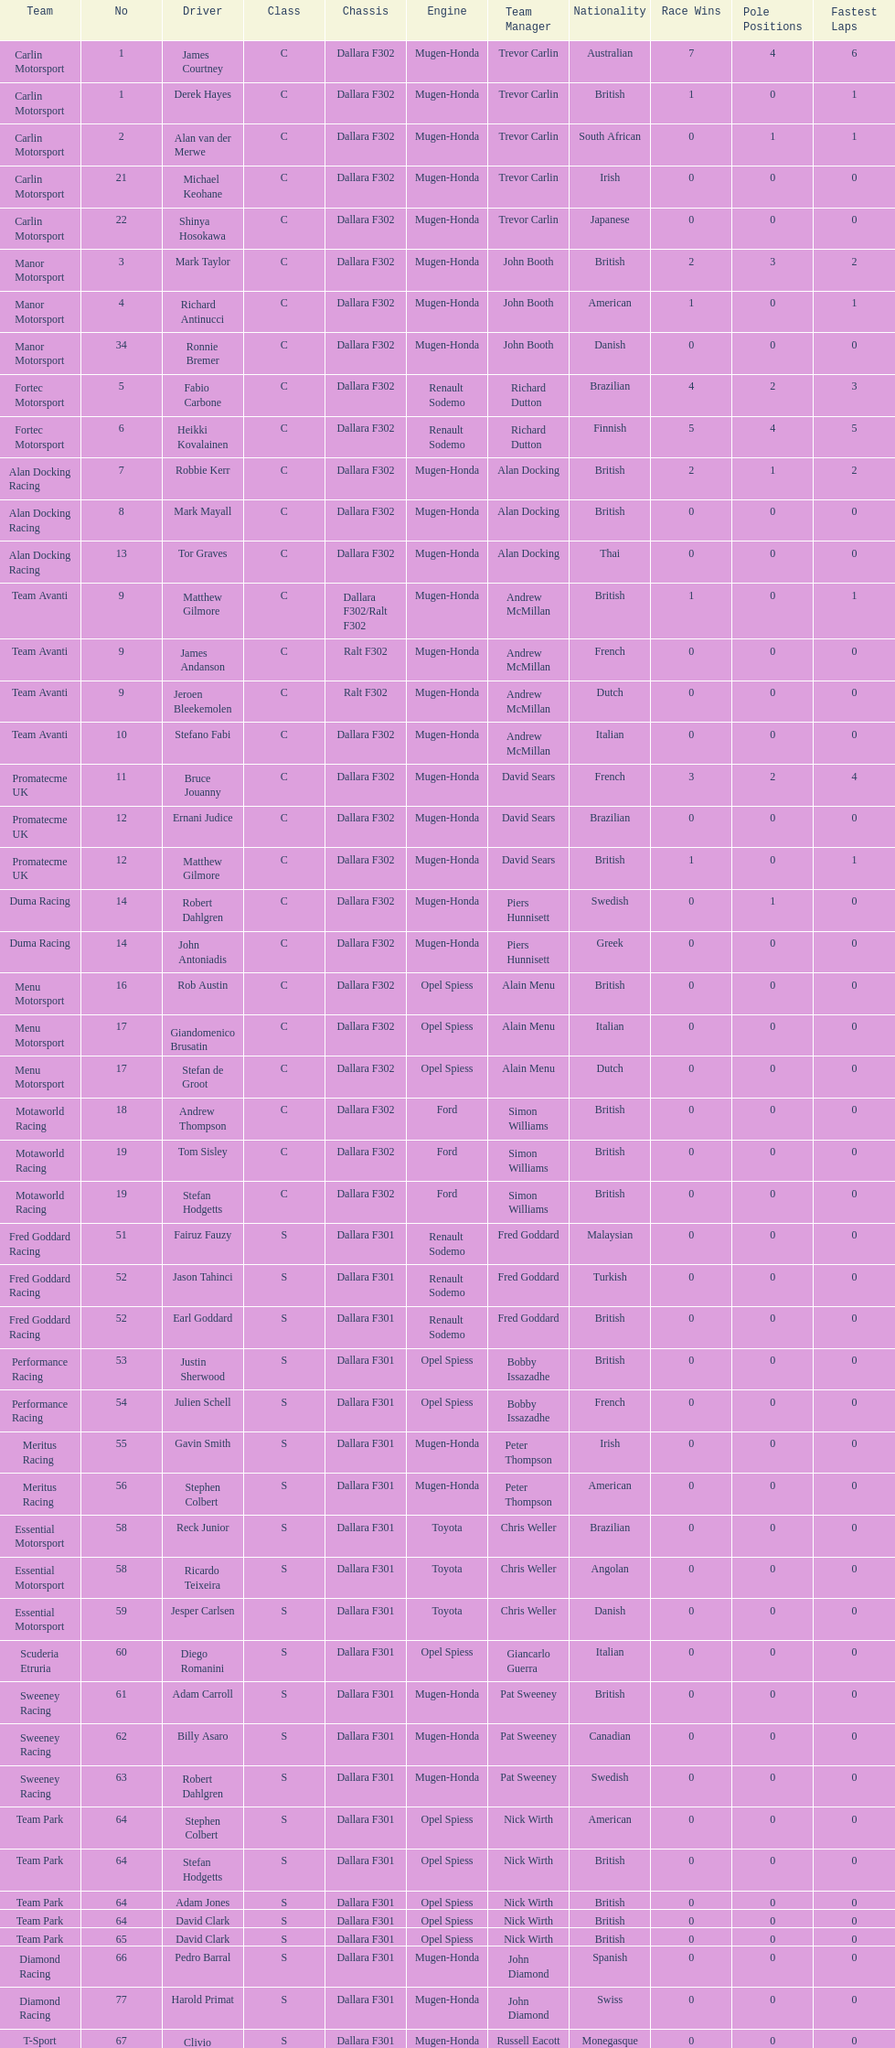How many class s (scholarship) teams are on the chart? 19. 